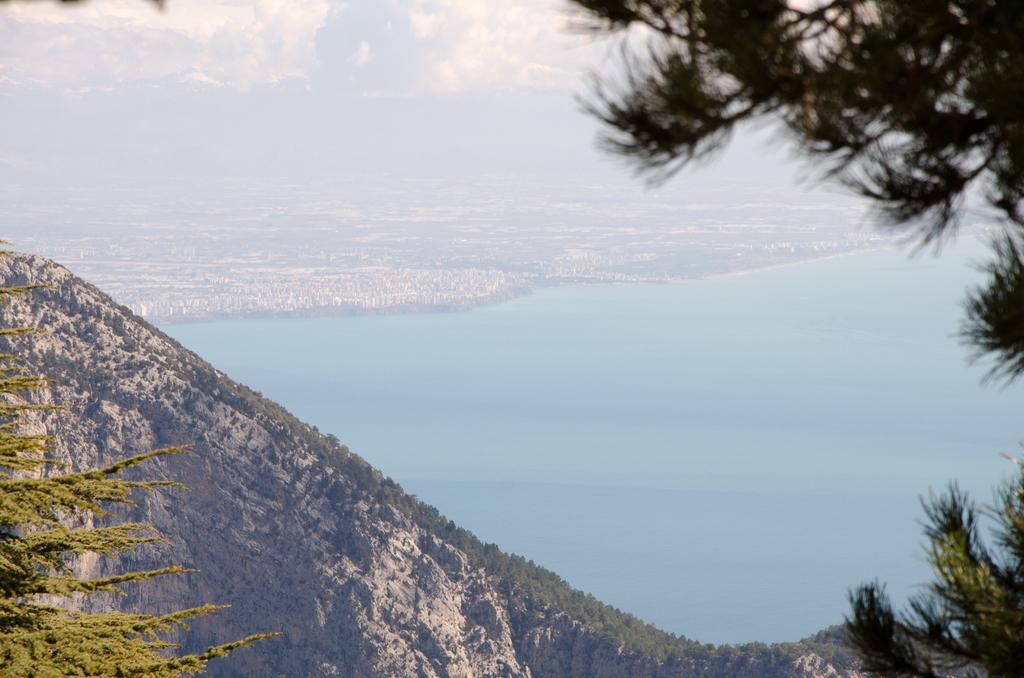What type of vegetation can be seen in the image? There are trees in the image. What geographical feature is present in the image? There is a hill in the image. What large body of water is visible in the image? There is an ocean visible in the image. What part of the natural environment is visible in the background of the image? The sky is visible in the background of the image. What atmospheric conditions can be observed in the sky? There are clouds in the sky. What time of day is it in the image, specifically in the afternoon? The time of day is not specified in the image, and there is no indication of the afternoon. How many cribs are visible in the image? There are no cribs present in the image. 